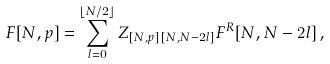Convert formula to latex. <formula><loc_0><loc_0><loc_500><loc_500>F [ N , p ] = \sum _ { l = 0 } ^ { \lfloor N / 2 \rfloor } Z _ { [ N , p ] \, [ N , N - 2 l ] } F ^ { R } [ N , N - 2 l ] \, ,</formula> 